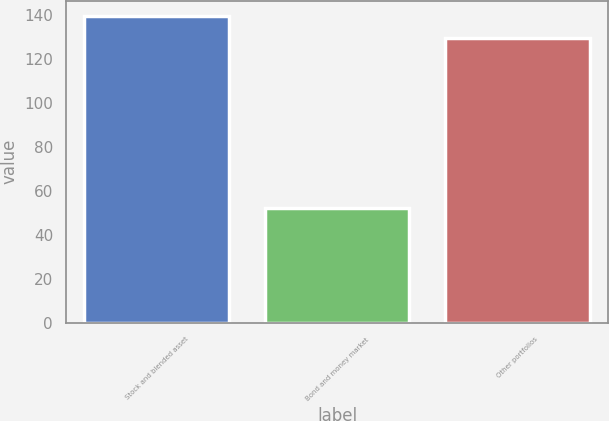<chart> <loc_0><loc_0><loc_500><loc_500><bar_chart><fcel>Stock and blended asset<fcel>Bond and money market<fcel>Other portfolios<nl><fcel>139.5<fcel>52.3<fcel>129.5<nl></chart> 